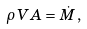Convert formula to latex. <formula><loc_0><loc_0><loc_500><loc_500>\rho \, V A = \dot { M } \, ,</formula> 